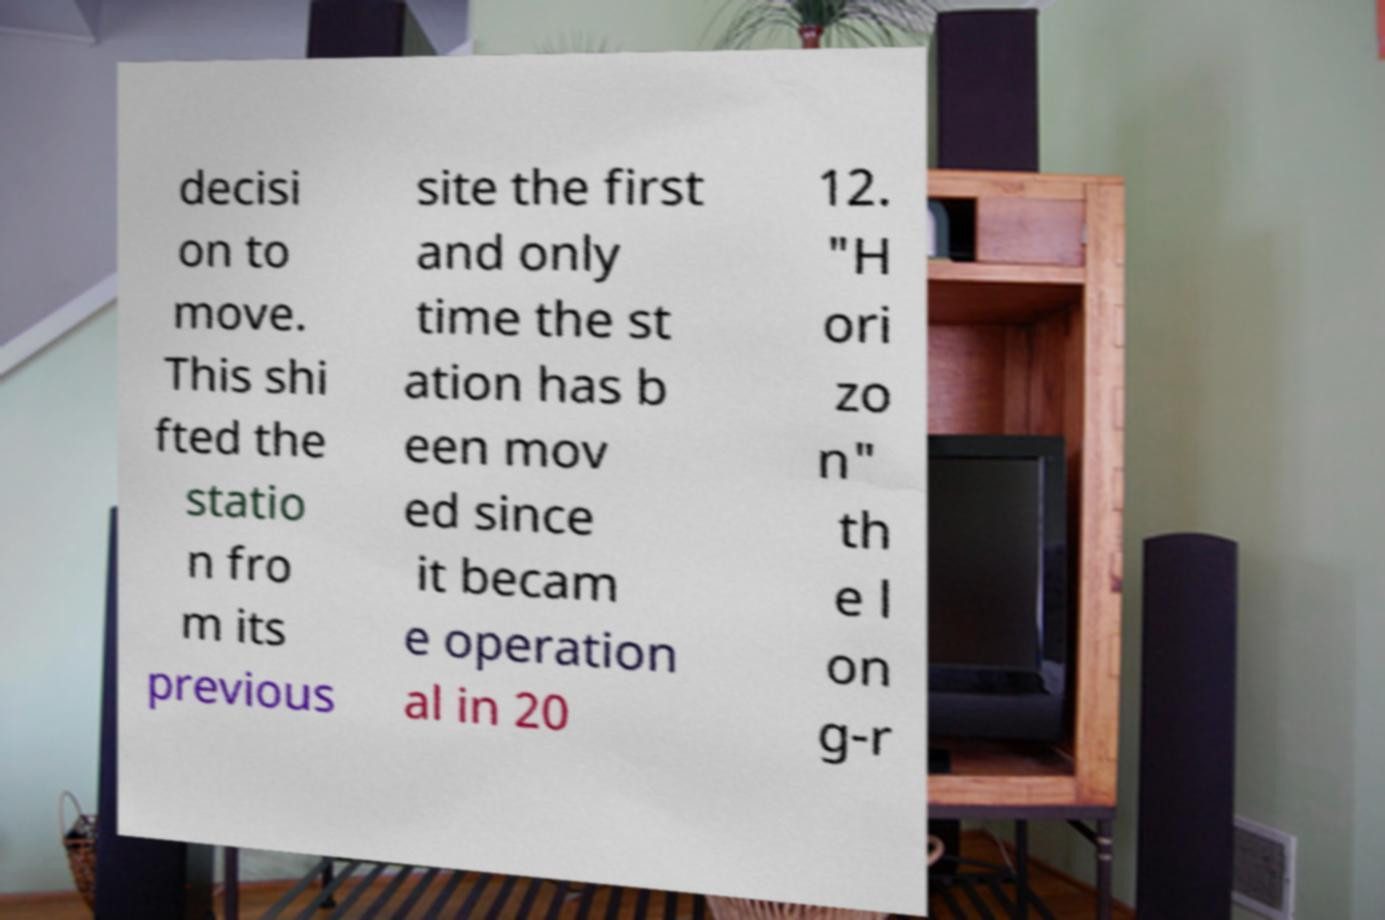Can you read and provide the text displayed in the image?This photo seems to have some interesting text. Can you extract and type it out for me? decisi on to move. This shi fted the statio n fro m its previous site the first and only time the st ation has b een mov ed since it becam e operation al in 20 12. "H ori zo n" th e l on g-r 